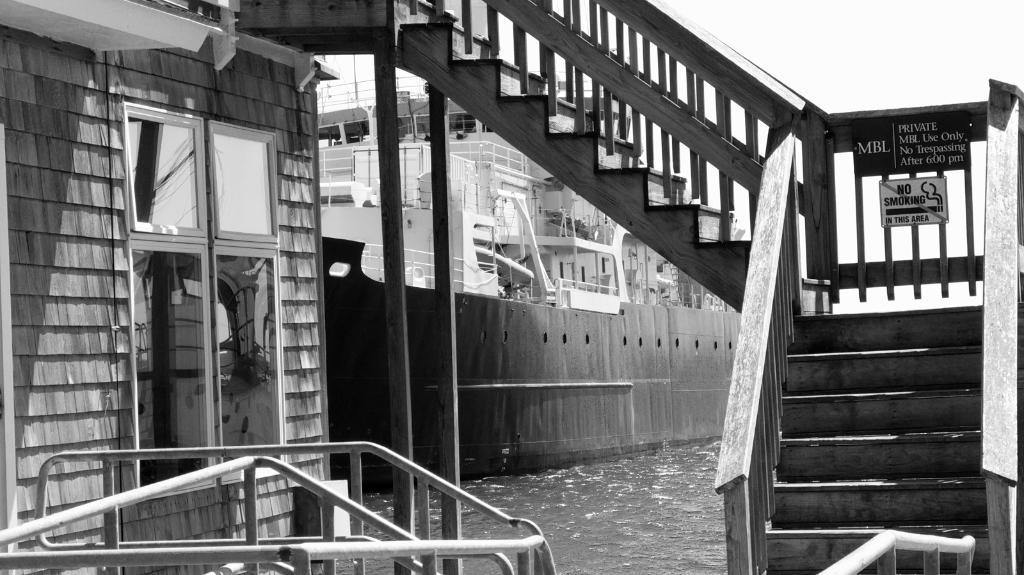What type of structure is present in the image? There are stairs in the image. What can be seen on the water in the image? There is a ship on the water in the image. What other objects are present in the image? There are poles in the image. What is visible in the background of the image? The sky is visible in the image. How is the image presented in terms of color? The image is black and white in color. How many men are holding sticks on the ship in the image? There are no men or sticks present on the ship in the image. What type of brake system is installed on the stairs in the image? There is no brake system present on the stairs in the image. 